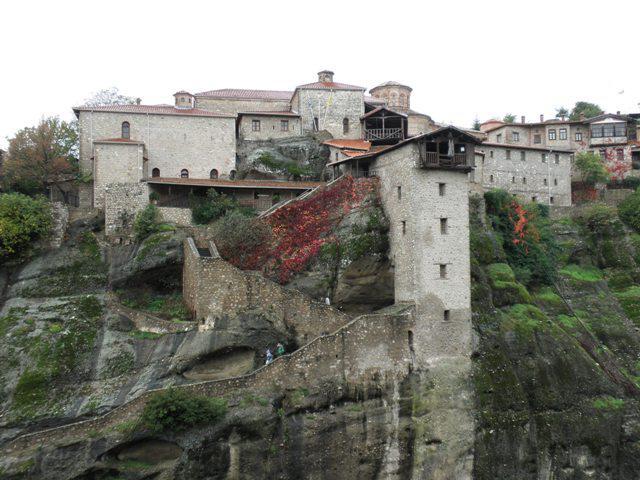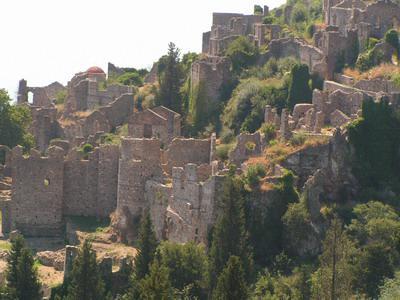The first image is the image on the left, the second image is the image on the right. For the images displayed, is the sentence "Right image features buildings with red-orange roofs on a rocky hilltop, while left image does not." factually correct? Answer yes or no. No. The first image is the image on the left, the second image is the image on the right. For the images displayed, is the sentence "Left image includes bright yellow foliage in front of a steep rocky formation topped with an orangish-roofed building." factually correct? Answer yes or no. No. 